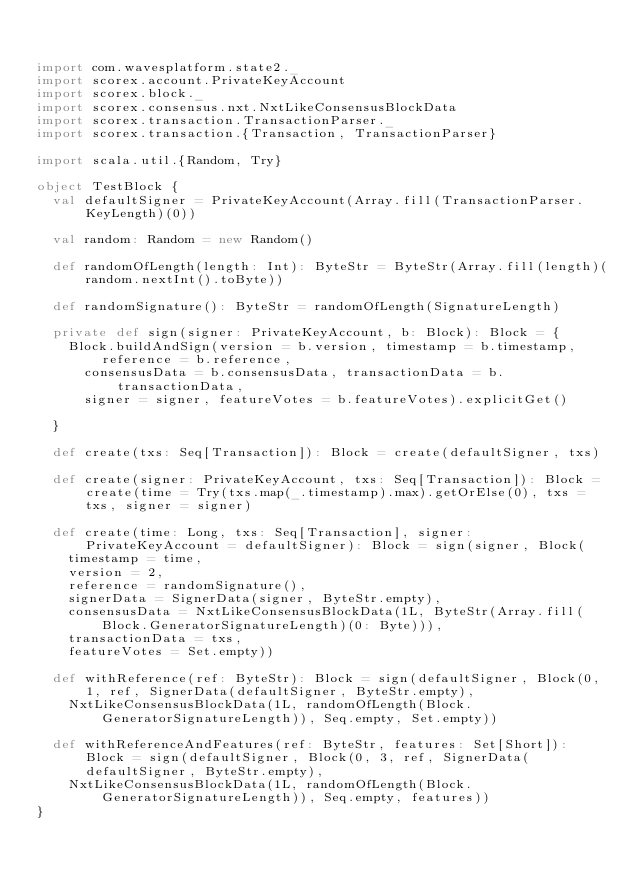<code> <loc_0><loc_0><loc_500><loc_500><_Scala_>

import com.wavesplatform.state2._
import scorex.account.PrivateKeyAccount
import scorex.block._
import scorex.consensus.nxt.NxtLikeConsensusBlockData
import scorex.transaction.TransactionParser._
import scorex.transaction.{Transaction, TransactionParser}

import scala.util.{Random, Try}

object TestBlock {
  val defaultSigner = PrivateKeyAccount(Array.fill(TransactionParser.KeyLength)(0))

  val random: Random = new Random()

  def randomOfLength(length: Int): ByteStr = ByteStr(Array.fill(length)(random.nextInt().toByte))

  def randomSignature(): ByteStr = randomOfLength(SignatureLength)

  private def sign(signer: PrivateKeyAccount, b: Block): Block = {
    Block.buildAndSign(version = b.version, timestamp = b.timestamp, reference = b.reference,
      consensusData = b.consensusData, transactionData = b.transactionData,
      signer = signer, featureVotes = b.featureVotes).explicitGet()

  }

  def create(txs: Seq[Transaction]): Block = create(defaultSigner, txs)

  def create(signer: PrivateKeyAccount, txs: Seq[Transaction]): Block = create(time = Try(txs.map(_.timestamp).max).getOrElse(0), txs = txs, signer = signer)

  def create(time: Long, txs: Seq[Transaction], signer: PrivateKeyAccount = defaultSigner): Block = sign(signer, Block(
    timestamp = time,
    version = 2,
    reference = randomSignature(),
    signerData = SignerData(signer, ByteStr.empty),
    consensusData = NxtLikeConsensusBlockData(1L, ByteStr(Array.fill(Block.GeneratorSignatureLength)(0: Byte))),
    transactionData = txs,
    featureVotes = Set.empty))

  def withReference(ref: ByteStr): Block = sign(defaultSigner, Block(0, 1, ref, SignerData(defaultSigner, ByteStr.empty),
    NxtLikeConsensusBlockData(1L, randomOfLength(Block.GeneratorSignatureLength)), Seq.empty, Set.empty))

  def withReferenceAndFeatures(ref: ByteStr, features: Set[Short]): Block = sign(defaultSigner, Block(0, 3, ref, SignerData(defaultSigner, ByteStr.empty),
    NxtLikeConsensusBlockData(1L, randomOfLength(Block.GeneratorSignatureLength)), Seq.empty, features))
}
</code> 